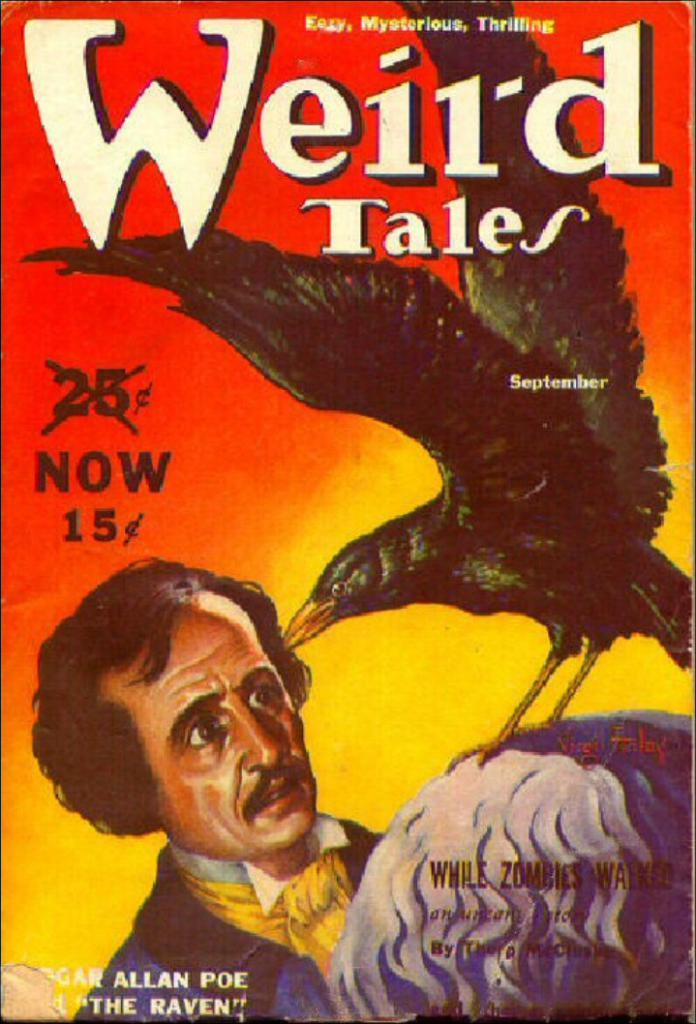<image>
Describe the image concisely. Weird Tales used to cost 25 cents but now it is only 15 cents. 